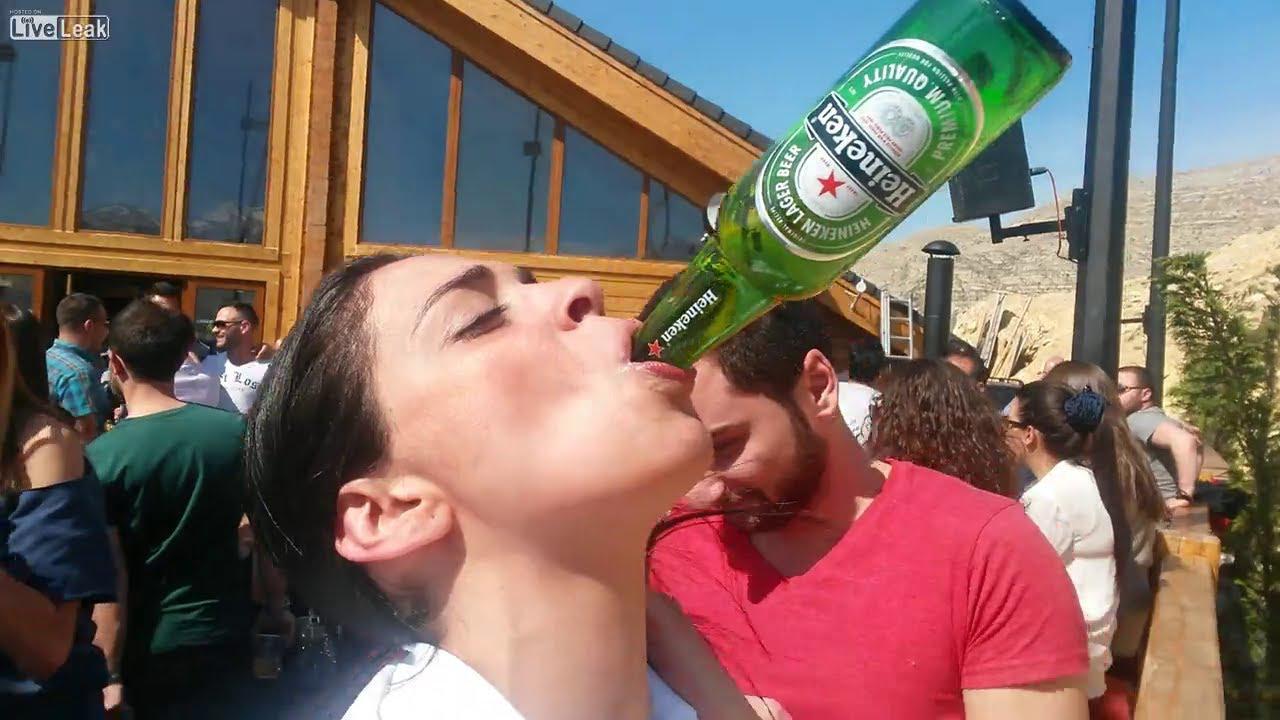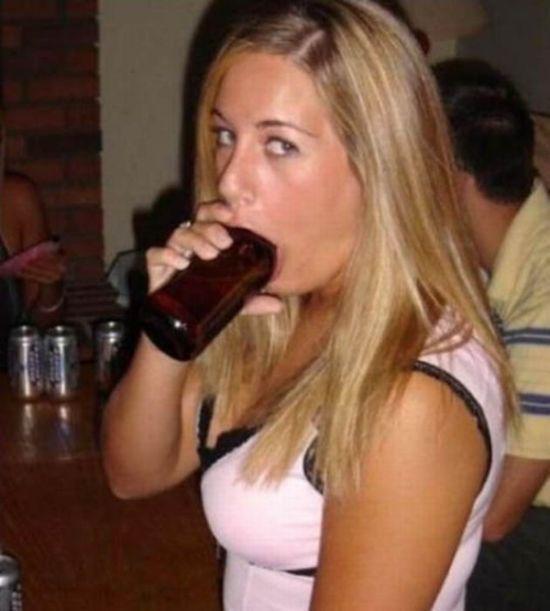The first image is the image on the left, the second image is the image on the right. Evaluate the accuracy of this statement regarding the images: "The woman in the image on the right is lifting a green bottle to her mouth.". Is it true? Answer yes or no. No. The first image is the image on the left, the second image is the image on the right. Examine the images to the left and right. Is the description "The top of a bottle is inside a woman's mouth." accurate? Answer yes or no. Yes. 